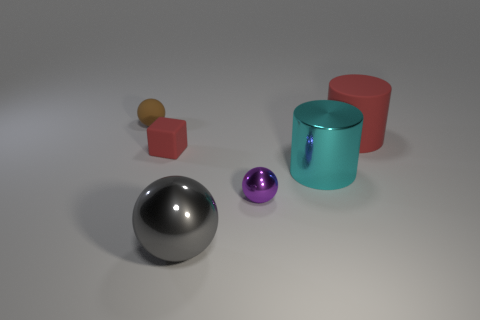Add 1 cyan rubber balls. How many objects exist? 7 Subtract all cylinders. How many objects are left? 4 Subtract 0 blue cylinders. How many objects are left? 6 Subtract all small red matte objects. Subtract all small metal cylinders. How many objects are left? 5 Add 3 small brown matte spheres. How many small brown matte spheres are left? 4 Add 1 small red matte objects. How many small red matte objects exist? 2 